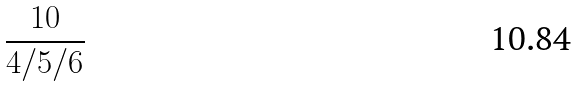<formula> <loc_0><loc_0><loc_500><loc_500>\frac { 1 0 } { 4 / 5 / 6 }</formula> 